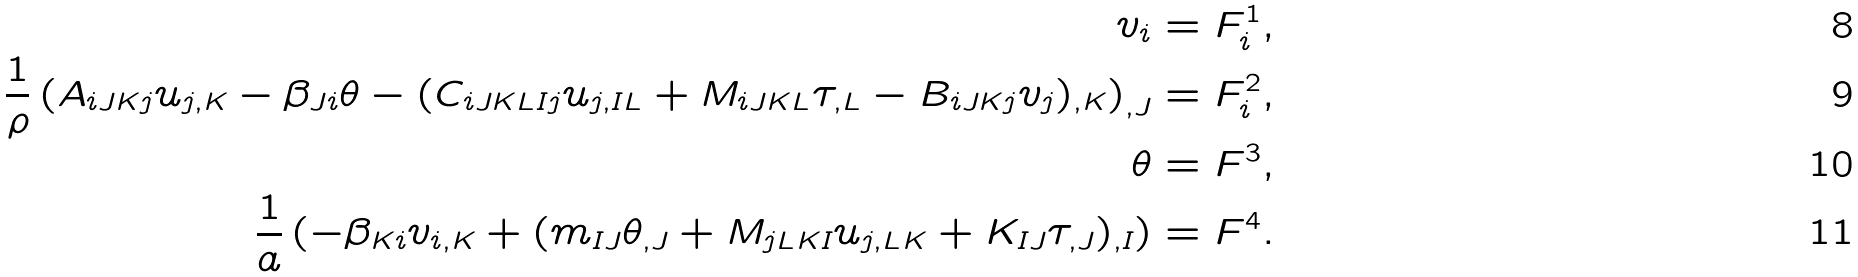Convert formula to latex. <formula><loc_0><loc_0><loc_500><loc_500>v _ { i } & = F ^ { 1 } _ { i } , \\ \frac { 1 } { \rho } \left ( A _ { i J K j } u _ { j , K } - \beta _ { J i } \theta - ( C _ { i J K L I j } u _ { j , I L } + M _ { i J K L } \tau _ { , L } - B _ { i J K j } v _ { j } ) _ { , K } \right ) _ { , J } & = F ^ { 2 } _ { i } , \\ \theta & = F ^ { 3 } , \\ \frac { 1 } { a } \left ( - \beta _ { K i } v _ { i , K } + ( m _ { I J } \theta _ { , J } + M _ { j L K I } u _ { j , L K } + K _ { I J } \tau _ { , J } ) _ { , I } \right ) & = F ^ { 4 } .</formula> 